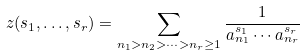Convert formula to latex. <formula><loc_0><loc_0><loc_500><loc_500>\ z ( s _ { 1 } , \dots , s _ { r } ) = \sum _ { n _ { 1 } > n _ { 2 } > \cdots > n _ { r } \geq 1 } \frac { 1 } { a _ { n _ { 1 } } ^ { s _ { 1 } } \cdots a _ { n _ { r } } ^ { s _ { r } } }</formula> 